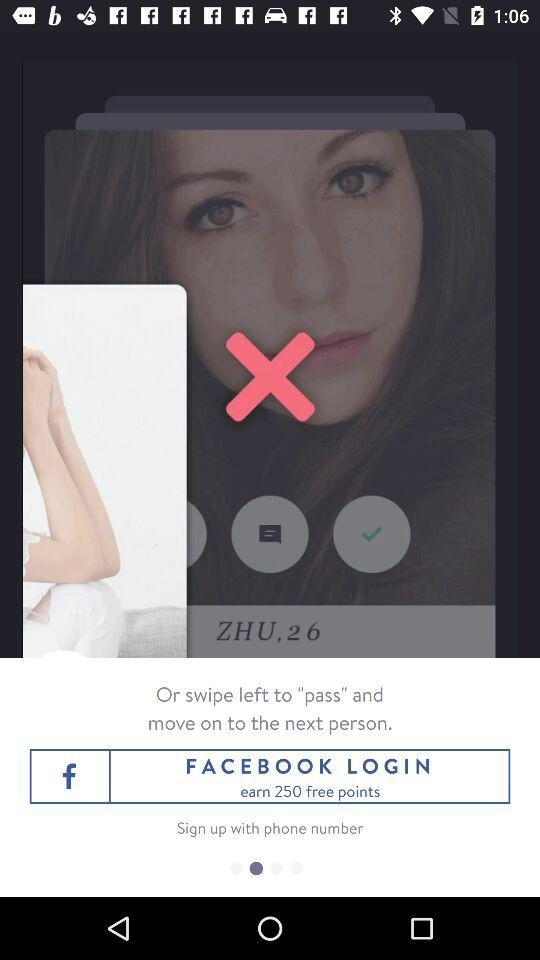Where does "ZHU" live?
When the provided information is insufficient, respond with <no answer>. <no answer> 